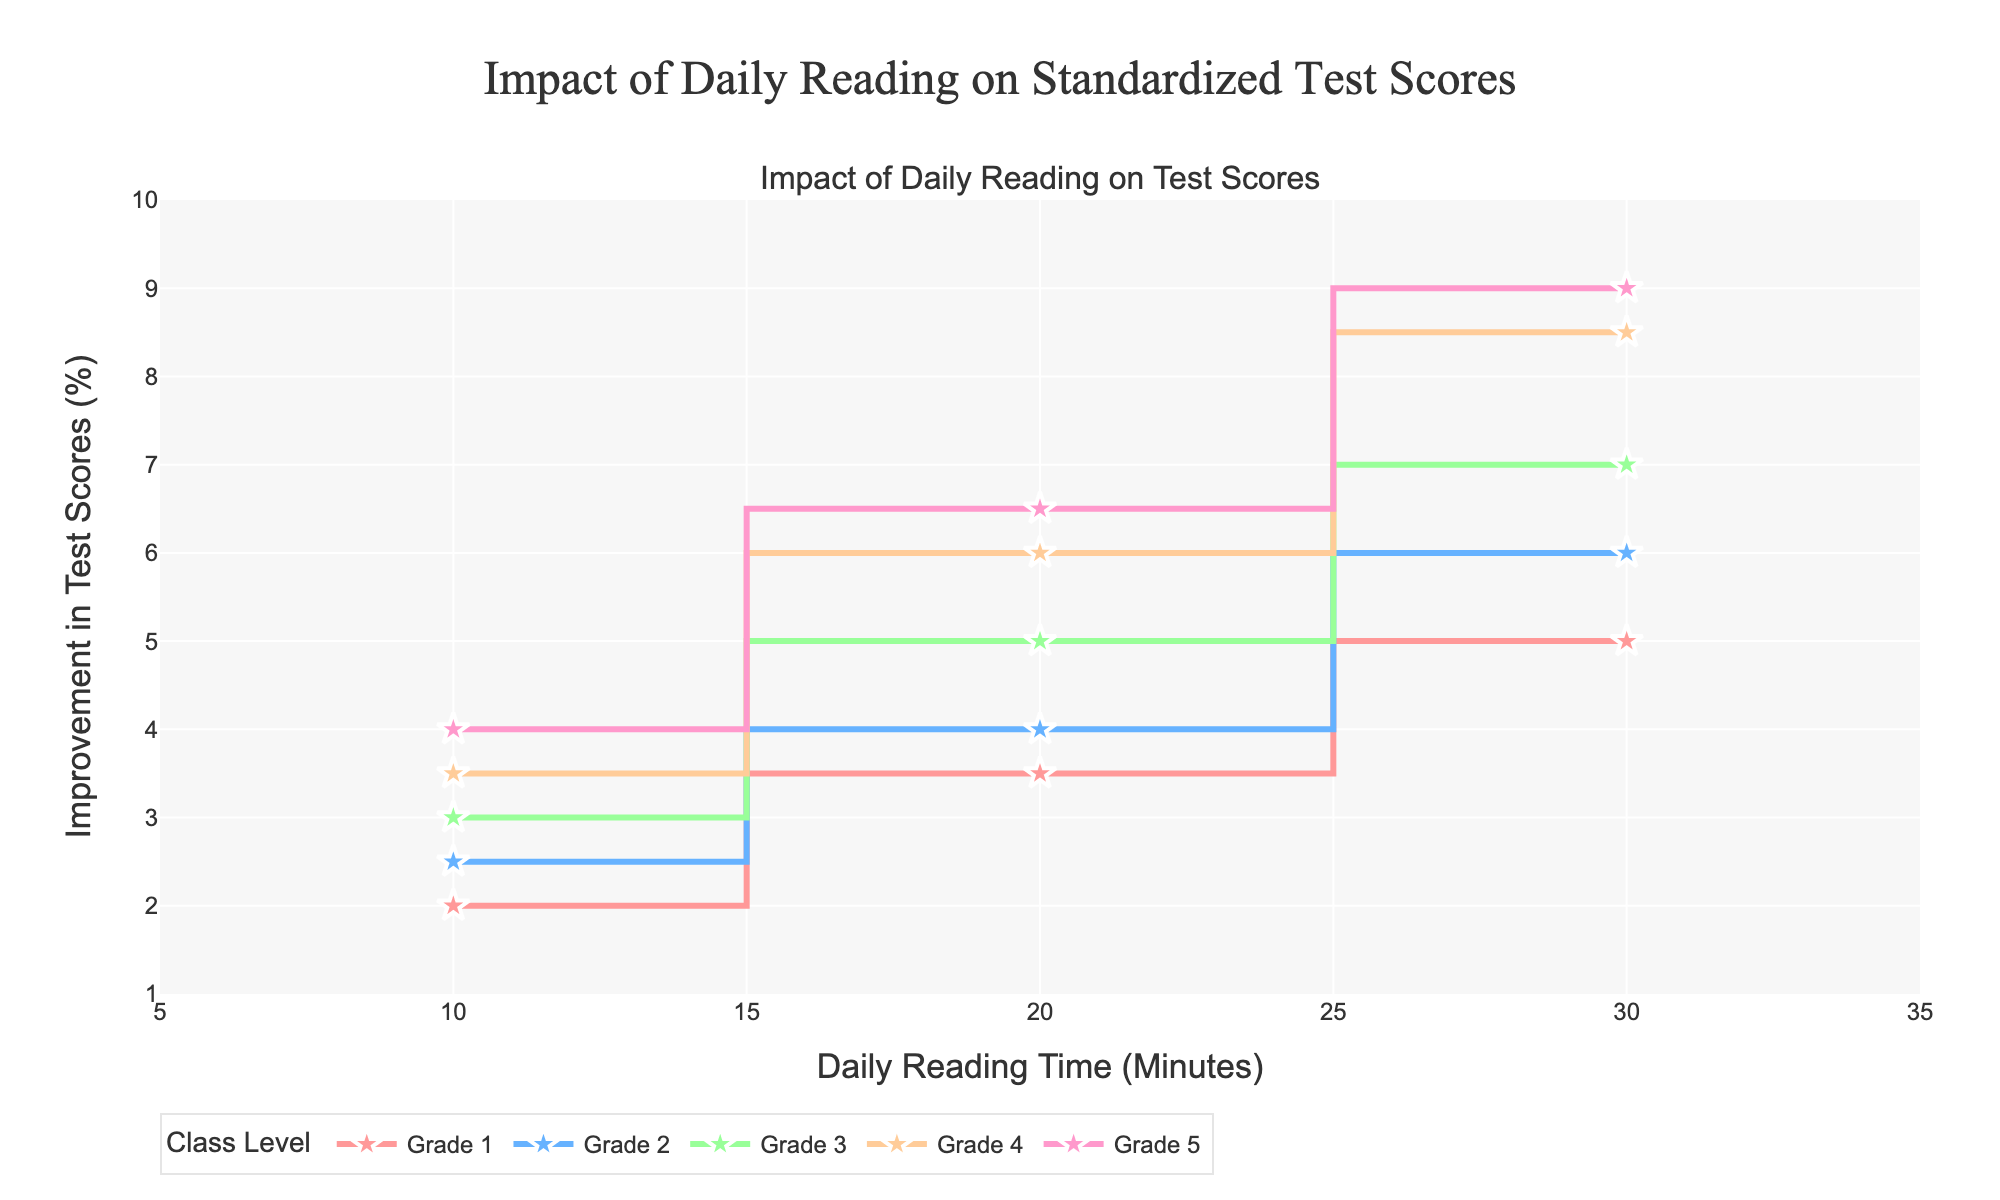What is the title of the plot? The title of the plot is given at the top of the figure. It is "Impact of Daily Reading on Standardized Test Scores".
Answer: Impact of Daily Reading on Standardized Test Scores What is the daily reading time range displayed on the x-axis? The x-axis range includes values from 5 to 35 minutes, as indicated by the axis ticks and labels.
Answer: 5 to 35 minutes Which class level shows the highest improvement in test scores for a daily reading time of 20 minutes? By observing the y-values for 20 minutes on the x-axis, the Grade 5 line reaches the highest point among all class levels.
Answer: Grade 5 How much difference in test score improvement is there between Grade 1 and Grade 3 for 30 minutes of daily reading time? At 30 minutes of reading, Grade 1 shows an improvement of 5%, while Grade 3 shows an improvement of 7%. The difference is calculated as 7% - 5% = 2%.
Answer: 2% What color is used to represent Grade 2 in the plot? The colors representing each class level are distinct. Grade 2 is represented by a specific color, which is light blue when observed in the plot.
Answer: Light Blue What is the average test score improvement for Grade 4 across all daily reading times shown? The test score improvements for Grade 4 are 3.5%, 6%, and 8.5% for 10, 20, and 30 minutes, respectively. The average is (3.5 + 6 + 8.5) / 3 = 18 / 3 = 6%.
Answer: 6% Which class level has the smallest improvement in test scores for 10 minutes of daily reading time? Looking at the 10-minute mark on the x-axis, Grade 1's line is the lowest among all class levels at 2%.
Answer: Grade 1 How does the test score improvement trend generally change as daily reading time increases? Observing the lines, all class levels show an increasing trend in the test score improvement as the daily reading time increases from 10 to 30 minutes.
Answer: Increases Are there any instances where increasing daily reading time does not result in a higher improvement in test scores for the same class level? By closely examining the plot, it can be seen that for every class level, the y-values either increase or stay the same as the daily reading time increases. There are no downturns.
Answer: No 